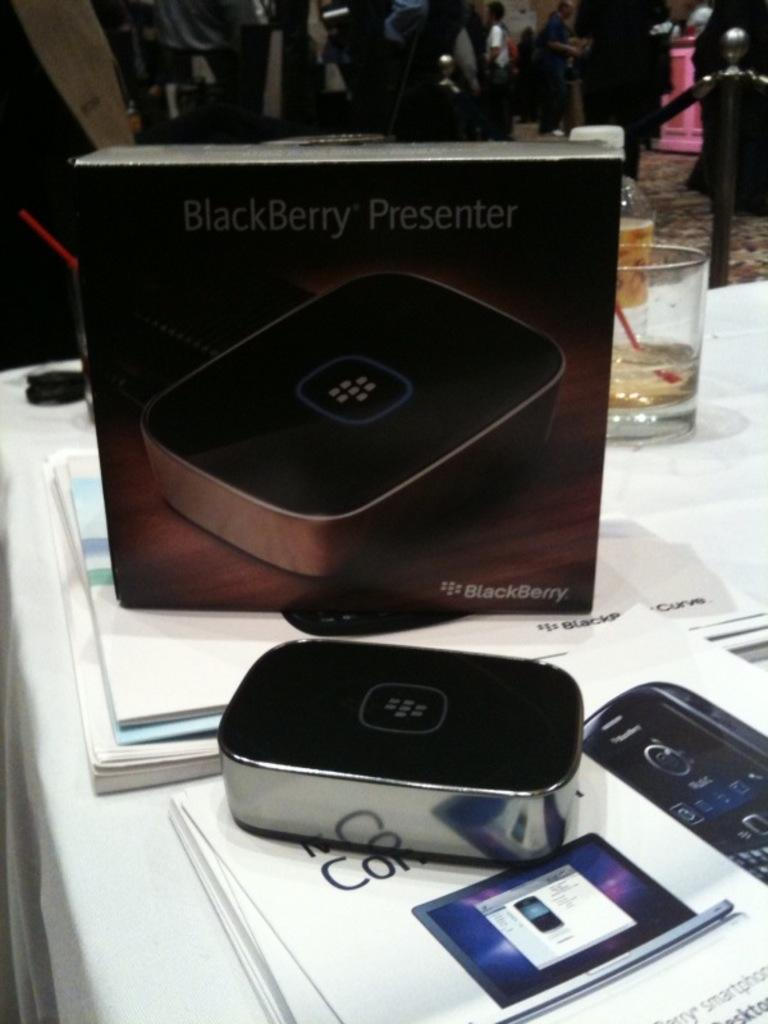<image>
Create a compact narrative representing the image presented. a Blackberry presenter that is in a box 